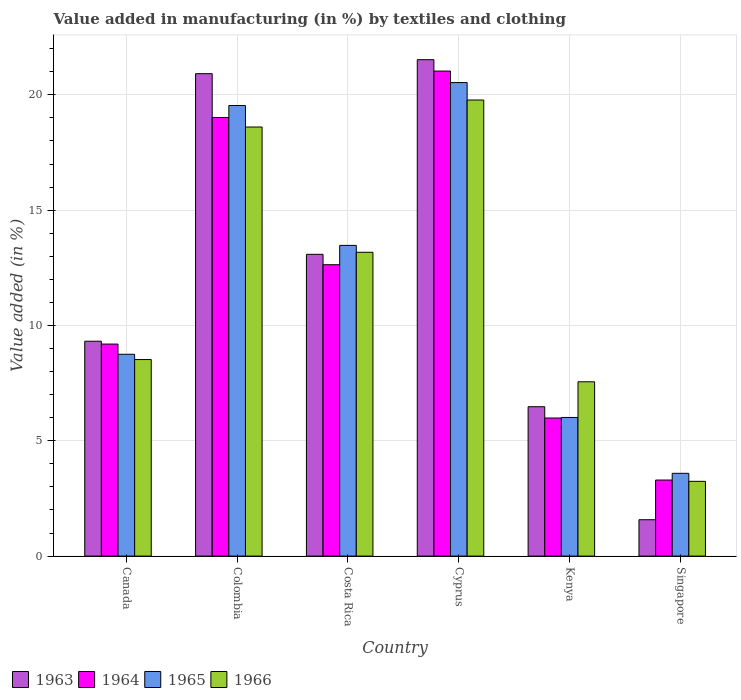How many groups of bars are there?
Offer a terse response. 6. Are the number of bars per tick equal to the number of legend labels?
Your answer should be compact. Yes. Are the number of bars on each tick of the X-axis equal?
Your answer should be compact. Yes. How many bars are there on the 5th tick from the left?
Your response must be concise. 4. How many bars are there on the 3rd tick from the right?
Provide a short and direct response. 4. What is the percentage of value added in manufacturing by textiles and clothing in 1965 in Colombia?
Your answer should be compact. 19.54. Across all countries, what is the maximum percentage of value added in manufacturing by textiles and clothing in 1966?
Ensure brevity in your answer.  19.78. Across all countries, what is the minimum percentage of value added in manufacturing by textiles and clothing in 1964?
Your answer should be very brief. 3.3. In which country was the percentage of value added in manufacturing by textiles and clothing in 1964 maximum?
Offer a terse response. Cyprus. In which country was the percentage of value added in manufacturing by textiles and clothing in 1966 minimum?
Give a very brief answer. Singapore. What is the total percentage of value added in manufacturing by textiles and clothing in 1965 in the graph?
Your answer should be compact. 71.89. What is the difference between the percentage of value added in manufacturing by textiles and clothing in 1963 in Colombia and that in Kenya?
Provide a short and direct response. 14.44. What is the difference between the percentage of value added in manufacturing by textiles and clothing in 1965 in Kenya and the percentage of value added in manufacturing by textiles and clothing in 1966 in Singapore?
Give a very brief answer. 2.77. What is the average percentage of value added in manufacturing by textiles and clothing in 1964 per country?
Keep it short and to the point. 11.86. What is the difference between the percentage of value added in manufacturing by textiles and clothing of/in 1963 and percentage of value added in manufacturing by textiles and clothing of/in 1965 in Cyprus?
Provide a short and direct response. 0.99. In how many countries, is the percentage of value added in manufacturing by textiles and clothing in 1964 greater than 7 %?
Offer a terse response. 4. What is the ratio of the percentage of value added in manufacturing by textiles and clothing in 1964 in Costa Rica to that in Cyprus?
Provide a succinct answer. 0.6. What is the difference between the highest and the second highest percentage of value added in manufacturing by textiles and clothing in 1964?
Your response must be concise. 6.38. What is the difference between the highest and the lowest percentage of value added in manufacturing by textiles and clothing in 1965?
Offer a terse response. 16.94. In how many countries, is the percentage of value added in manufacturing by textiles and clothing in 1963 greater than the average percentage of value added in manufacturing by textiles and clothing in 1963 taken over all countries?
Give a very brief answer. 3. What does the 1st bar from the left in Singapore represents?
Provide a short and direct response. 1963. What does the 1st bar from the right in Kenya represents?
Offer a very short reply. 1966. Is it the case that in every country, the sum of the percentage of value added in manufacturing by textiles and clothing in 1964 and percentage of value added in manufacturing by textiles and clothing in 1965 is greater than the percentage of value added in manufacturing by textiles and clothing in 1963?
Provide a short and direct response. Yes. Are all the bars in the graph horizontal?
Make the answer very short. No. What is the difference between two consecutive major ticks on the Y-axis?
Keep it short and to the point. 5. Are the values on the major ticks of Y-axis written in scientific E-notation?
Offer a very short reply. No. How many legend labels are there?
Offer a very short reply. 4. How are the legend labels stacked?
Your answer should be very brief. Horizontal. What is the title of the graph?
Offer a terse response. Value added in manufacturing (in %) by textiles and clothing. Does "1991" appear as one of the legend labels in the graph?
Provide a succinct answer. No. What is the label or title of the X-axis?
Offer a terse response. Country. What is the label or title of the Y-axis?
Provide a short and direct response. Value added (in %). What is the Value added (in %) in 1963 in Canada?
Offer a very short reply. 9.32. What is the Value added (in %) in 1964 in Canada?
Make the answer very short. 9.19. What is the Value added (in %) in 1965 in Canada?
Your answer should be very brief. 8.75. What is the Value added (in %) of 1966 in Canada?
Give a very brief answer. 8.52. What is the Value added (in %) in 1963 in Colombia?
Your answer should be compact. 20.92. What is the Value added (in %) in 1964 in Colombia?
Offer a terse response. 19.02. What is the Value added (in %) of 1965 in Colombia?
Offer a terse response. 19.54. What is the Value added (in %) in 1966 in Colombia?
Provide a short and direct response. 18.6. What is the Value added (in %) of 1963 in Costa Rica?
Your answer should be compact. 13.08. What is the Value added (in %) in 1964 in Costa Rica?
Keep it short and to the point. 12.63. What is the Value added (in %) in 1965 in Costa Rica?
Offer a very short reply. 13.47. What is the Value added (in %) in 1966 in Costa Rica?
Keep it short and to the point. 13.17. What is the Value added (in %) in 1963 in Cyprus?
Ensure brevity in your answer.  21.52. What is the Value added (in %) in 1964 in Cyprus?
Ensure brevity in your answer.  21.03. What is the Value added (in %) in 1965 in Cyprus?
Make the answer very short. 20.53. What is the Value added (in %) in 1966 in Cyprus?
Give a very brief answer. 19.78. What is the Value added (in %) of 1963 in Kenya?
Offer a terse response. 6.48. What is the Value added (in %) in 1964 in Kenya?
Your answer should be compact. 5.99. What is the Value added (in %) of 1965 in Kenya?
Make the answer very short. 6.01. What is the Value added (in %) in 1966 in Kenya?
Your answer should be compact. 7.56. What is the Value added (in %) in 1963 in Singapore?
Provide a succinct answer. 1.58. What is the Value added (in %) in 1964 in Singapore?
Your response must be concise. 3.3. What is the Value added (in %) in 1965 in Singapore?
Keep it short and to the point. 3.59. What is the Value added (in %) in 1966 in Singapore?
Ensure brevity in your answer.  3.24. Across all countries, what is the maximum Value added (in %) of 1963?
Offer a very short reply. 21.52. Across all countries, what is the maximum Value added (in %) in 1964?
Your response must be concise. 21.03. Across all countries, what is the maximum Value added (in %) in 1965?
Your answer should be compact. 20.53. Across all countries, what is the maximum Value added (in %) of 1966?
Ensure brevity in your answer.  19.78. Across all countries, what is the minimum Value added (in %) in 1963?
Give a very brief answer. 1.58. Across all countries, what is the minimum Value added (in %) of 1964?
Give a very brief answer. 3.3. Across all countries, what is the minimum Value added (in %) in 1965?
Give a very brief answer. 3.59. Across all countries, what is the minimum Value added (in %) in 1966?
Your answer should be compact. 3.24. What is the total Value added (in %) of 1963 in the graph?
Your response must be concise. 72.9. What is the total Value added (in %) in 1964 in the graph?
Give a very brief answer. 71.16. What is the total Value added (in %) in 1965 in the graph?
Ensure brevity in your answer.  71.89. What is the total Value added (in %) of 1966 in the graph?
Offer a very short reply. 70.87. What is the difference between the Value added (in %) in 1963 in Canada and that in Colombia?
Provide a short and direct response. -11.6. What is the difference between the Value added (in %) of 1964 in Canada and that in Colombia?
Ensure brevity in your answer.  -9.82. What is the difference between the Value added (in %) in 1965 in Canada and that in Colombia?
Provide a succinct answer. -10.79. What is the difference between the Value added (in %) in 1966 in Canada and that in Colombia?
Your answer should be compact. -10.08. What is the difference between the Value added (in %) of 1963 in Canada and that in Costa Rica?
Offer a terse response. -3.77. What is the difference between the Value added (in %) of 1964 in Canada and that in Costa Rica?
Make the answer very short. -3.44. What is the difference between the Value added (in %) in 1965 in Canada and that in Costa Rica?
Ensure brevity in your answer.  -4.72. What is the difference between the Value added (in %) in 1966 in Canada and that in Costa Rica?
Provide a short and direct response. -4.65. What is the difference between the Value added (in %) in 1963 in Canada and that in Cyprus?
Offer a very short reply. -12.21. What is the difference between the Value added (in %) in 1964 in Canada and that in Cyprus?
Your answer should be very brief. -11.84. What is the difference between the Value added (in %) in 1965 in Canada and that in Cyprus?
Your response must be concise. -11.78. What is the difference between the Value added (in %) of 1966 in Canada and that in Cyprus?
Ensure brevity in your answer.  -11.25. What is the difference between the Value added (in %) in 1963 in Canada and that in Kenya?
Offer a very short reply. 2.84. What is the difference between the Value added (in %) in 1964 in Canada and that in Kenya?
Offer a very short reply. 3.21. What is the difference between the Value added (in %) in 1965 in Canada and that in Kenya?
Keep it short and to the point. 2.74. What is the difference between the Value added (in %) of 1966 in Canada and that in Kenya?
Your answer should be very brief. 0.96. What is the difference between the Value added (in %) in 1963 in Canada and that in Singapore?
Provide a succinct answer. 7.74. What is the difference between the Value added (in %) in 1964 in Canada and that in Singapore?
Give a very brief answer. 5.9. What is the difference between the Value added (in %) in 1965 in Canada and that in Singapore?
Ensure brevity in your answer.  5.16. What is the difference between the Value added (in %) of 1966 in Canada and that in Singapore?
Your response must be concise. 5.28. What is the difference between the Value added (in %) in 1963 in Colombia and that in Costa Rica?
Offer a terse response. 7.83. What is the difference between the Value added (in %) in 1964 in Colombia and that in Costa Rica?
Ensure brevity in your answer.  6.38. What is the difference between the Value added (in %) in 1965 in Colombia and that in Costa Rica?
Your answer should be compact. 6.06. What is the difference between the Value added (in %) of 1966 in Colombia and that in Costa Rica?
Provide a short and direct response. 5.43. What is the difference between the Value added (in %) of 1963 in Colombia and that in Cyprus?
Keep it short and to the point. -0.61. What is the difference between the Value added (in %) of 1964 in Colombia and that in Cyprus?
Your answer should be very brief. -2.01. What is the difference between the Value added (in %) of 1965 in Colombia and that in Cyprus?
Your response must be concise. -0.99. What is the difference between the Value added (in %) of 1966 in Colombia and that in Cyprus?
Your answer should be very brief. -1.17. What is the difference between the Value added (in %) of 1963 in Colombia and that in Kenya?
Provide a short and direct response. 14.44. What is the difference between the Value added (in %) of 1964 in Colombia and that in Kenya?
Offer a very short reply. 13.03. What is the difference between the Value added (in %) of 1965 in Colombia and that in Kenya?
Your answer should be compact. 13.53. What is the difference between the Value added (in %) in 1966 in Colombia and that in Kenya?
Your answer should be very brief. 11.05. What is the difference between the Value added (in %) of 1963 in Colombia and that in Singapore?
Offer a very short reply. 19.34. What is the difference between the Value added (in %) of 1964 in Colombia and that in Singapore?
Your answer should be compact. 15.72. What is the difference between the Value added (in %) of 1965 in Colombia and that in Singapore?
Your answer should be compact. 15.95. What is the difference between the Value added (in %) in 1966 in Colombia and that in Singapore?
Give a very brief answer. 15.36. What is the difference between the Value added (in %) of 1963 in Costa Rica and that in Cyprus?
Your answer should be very brief. -8.44. What is the difference between the Value added (in %) of 1964 in Costa Rica and that in Cyprus?
Provide a succinct answer. -8.4. What is the difference between the Value added (in %) of 1965 in Costa Rica and that in Cyprus?
Your answer should be compact. -7.06. What is the difference between the Value added (in %) of 1966 in Costa Rica and that in Cyprus?
Give a very brief answer. -6.6. What is the difference between the Value added (in %) of 1963 in Costa Rica and that in Kenya?
Give a very brief answer. 6.61. What is the difference between the Value added (in %) of 1964 in Costa Rica and that in Kenya?
Your response must be concise. 6.65. What is the difference between the Value added (in %) in 1965 in Costa Rica and that in Kenya?
Make the answer very short. 7.46. What is the difference between the Value added (in %) in 1966 in Costa Rica and that in Kenya?
Ensure brevity in your answer.  5.62. What is the difference between the Value added (in %) in 1963 in Costa Rica and that in Singapore?
Your answer should be compact. 11.51. What is the difference between the Value added (in %) in 1964 in Costa Rica and that in Singapore?
Give a very brief answer. 9.34. What is the difference between the Value added (in %) in 1965 in Costa Rica and that in Singapore?
Give a very brief answer. 9.88. What is the difference between the Value added (in %) in 1966 in Costa Rica and that in Singapore?
Offer a terse response. 9.93. What is the difference between the Value added (in %) in 1963 in Cyprus and that in Kenya?
Give a very brief answer. 15.05. What is the difference between the Value added (in %) in 1964 in Cyprus and that in Kenya?
Offer a very short reply. 15.04. What is the difference between the Value added (in %) of 1965 in Cyprus and that in Kenya?
Offer a terse response. 14.52. What is the difference between the Value added (in %) in 1966 in Cyprus and that in Kenya?
Your response must be concise. 12.22. What is the difference between the Value added (in %) of 1963 in Cyprus and that in Singapore?
Provide a short and direct response. 19.95. What is the difference between the Value added (in %) in 1964 in Cyprus and that in Singapore?
Provide a short and direct response. 17.73. What is the difference between the Value added (in %) in 1965 in Cyprus and that in Singapore?
Your answer should be very brief. 16.94. What is the difference between the Value added (in %) in 1966 in Cyprus and that in Singapore?
Make the answer very short. 16.53. What is the difference between the Value added (in %) in 1963 in Kenya and that in Singapore?
Your answer should be very brief. 4.9. What is the difference between the Value added (in %) of 1964 in Kenya and that in Singapore?
Offer a very short reply. 2.69. What is the difference between the Value added (in %) in 1965 in Kenya and that in Singapore?
Your answer should be very brief. 2.42. What is the difference between the Value added (in %) in 1966 in Kenya and that in Singapore?
Offer a terse response. 4.32. What is the difference between the Value added (in %) of 1963 in Canada and the Value added (in %) of 1964 in Colombia?
Offer a very short reply. -9.7. What is the difference between the Value added (in %) in 1963 in Canada and the Value added (in %) in 1965 in Colombia?
Make the answer very short. -10.22. What is the difference between the Value added (in %) in 1963 in Canada and the Value added (in %) in 1966 in Colombia?
Provide a short and direct response. -9.29. What is the difference between the Value added (in %) of 1964 in Canada and the Value added (in %) of 1965 in Colombia?
Keep it short and to the point. -10.34. What is the difference between the Value added (in %) of 1964 in Canada and the Value added (in %) of 1966 in Colombia?
Keep it short and to the point. -9.41. What is the difference between the Value added (in %) of 1965 in Canada and the Value added (in %) of 1966 in Colombia?
Provide a short and direct response. -9.85. What is the difference between the Value added (in %) in 1963 in Canada and the Value added (in %) in 1964 in Costa Rica?
Offer a terse response. -3.32. What is the difference between the Value added (in %) in 1963 in Canada and the Value added (in %) in 1965 in Costa Rica?
Keep it short and to the point. -4.16. What is the difference between the Value added (in %) in 1963 in Canada and the Value added (in %) in 1966 in Costa Rica?
Give a very brief answer. -3.86. What is the difference between the Value added (in %) of 1964 in Canada and the Value added (in %) of 1965 in Costa Rica?
Offer a very short reply. -4.28. What is the difference between the Value added (in %) in 1964 in Canada and the Value added (in %) in 1966 in Costa Rica?
Make the answer very short. -3.98. What is the difference between the Value added (in %) in 1965 in Canada and the Value added (in %) in 1966 in Costa Rica?
Provide a succinct answer. -4.42. What is the difference between the Value added (in %) in 1963 in Canada and the Value added (in %) in 1964 in Cyprus?
Provide a succinct answer. -11.71. What is the difference between the Value added (in %) in 1963 in Canada and the Value added (in %) in 1965 in Cyprus?
Provide a succinct answer. -11.21. What is the difference between the Value added (in %) in 1963 in Canada and the Value added (in %) in 1966 in Cyprus?
Make the answer very short. -10.46. What is the difference between the Value added (in %) in 1964 in Canada and the Value added (in %) in 1965 in Cyprus?
Your answer should be compact. -11.34. What is the difference between the Value added (in %) of 1964 in Canada and the Value added (in %) of 1966 in Cyprus?
Offer a terse response. -10.58. What is the difference between the Value added (in %) in 1965 in Canada and the Value added (in %) in 1966 in Cyprus?
Provide a short and direct response. -11.02. What is the difference between the Value added (in %) of 1963 in Canada and the Value added (in %) of 1964 in Kenya?
Your response must be concise. 3.33. What is the difference between the Value added (in %) of 1963 in Canada and the Value added (in %) of 1965 in Kenya?
Provide a short and direct response. 3.31. What is the difference between the Value added (in %) of 1963 in Canada and the Value added (in %) of 1966 in Kenya?
Offer a very short reply. 1.76. What is the difference between the Value added (in %) of 1964 in Canada and the Value added (in %) of 1965 in Kenya?
Keep it short and to the point. 3.18. What is the difference between the Value added (in %) of 1964 in Canada and the Value added (in %) of 1966 in Kenya?
Offer a very short reply. 1.64. What is the difference between the Value added (in %) of 1965 in Canada and the Value added (in %) of 1966 in Kenya?
Give a very brief answer. 1.19. What is the difference between the Value added (in %) in 1963 in Canada and the Value added (in %) in 1964 in Singapore?
Your response must be concise. 6.02. What is the difference between the Value added (in %) in 1963 in Canada and the Value added (in %) in 1965 in Singapore?
Your response must be concise. 5.73. What is the difference between the Value added (in %) in 1963 in Canada and the Value added (in %) in 1966 in Singapore?
Ensure brevity in your answer.  6.08. What is the difference between the Value added (in %) in 1964 in Canada and the Value added (in %) in 1965 in Singapore?
Give a very brief answer. 5.6. What is the difference between the Value added (in %) in 1964 in Canada and the Value added (in %) in 1966 in Singapore?
Your answer should be very brief. 5.95. What is the difference between the Value added (in %) of 1965 in Canada and the Value added (in %) of 1966 in Singapore?
Keep it short and to the point. 5.51. What is the difference between the Value added (in %) in 1963 in Colombia and the Value added (in %) in 1964 in Costa Rica?
Provide a succinct answer. 8.28. What is the difference between the Value added (in %) in 1963 in Colombia and the Value added (in %) in 1965 in Costa Rica?
Give a very brief answer. 7.44. What is the difference between the Value added (in %) of 1963 in Colombia and the Value added (in %) of 1966 in Costa Rica?
Offer a terse response. 7.74. What is the difference between the Value added (in %) in 1964 in Colombia and the Value added (in %) in 1965 in Costa Rica?
Keep it short and to the point. 5.55. What is the difference between the Value added (in %) in 1964 in Colombia and the Value added (in %) in 1966 in Costa Rica?
Your answer should be very brief. 5.84. What is the difference between the Value added (in %) of 1965 in Colombia and the Value added (in %) of 1966 in Costa Rica?
Give a very brief answer. 6.36. What is the difference between the Value added (in %) in 1963 in Colombia and the Value added (in %) in 1964 in Cyprus?
Give a very brief answer. -0.11. What is the difference between the Value added (in %) in 1963 in Colombia and the Value added (in %) in 1965 in Cyprus?
Ensure brevity in your answer.  0.39. What is the difference between the Value added (in %) of 1963 in Colombia and the Value added (in %) of 1966 in Cyprus?
Ensure brevity in your answer.  1.14. What is the difference between the Value added (in %) of 1964 in Colombia and the Value added (in %) of 1965 in Cyprus?
Keep it short and to the point. -1.51. What is the difference between the Value added (in %) in 1964 in Colombia and the Value added (in %) in 1966 in Cyprus?
Give a very brief answer. -0.76. What is the difference between the Value added (in %) in 1965 in Colombia and the Value added (in %) in 1966 in Cyprus?
Give a very brief answer. -0.24. What is the difference between the Value added (in %) in 1963 in Colombia and the Value added (in %) in 1964 in Kenya?
Keep it short and to the point. 14.93. What is the difference between the Value added (in %) in 1963 in Colombia and the Value added (in %) in 1965 in Kenya?
Make the answer very short. 14.91. What is the difference between the Value added (in %) in 1963 in Colombia and the Value added (in %) in 1966 in Kenya?
Provide a short and direct response. 13.36. What is the difference between the Value added (in %) in 1964 in Colombia and the Value added (in %) in 1965 in Kenya?
Ensure brevity in your answer.  13.01. What is the difference between the Value added (in %) in 1964 in Colombia and the Value added (in %) in 1966 in Kenya?
Provide a succinct answer. 11.46. What is the difference between the Value added (in %) in 1965 in Colombia and the Value added (in %) in 1966 in Kenya?
Provide a short and direct response. 11.98. What is the difference between the Value added (in %) in 1963 in Colombia and the Value added (in %) in 1964 in Singapore?
Offer a terse response. 17.62. What is the difference between the Value added (in %) in 1963 in Colombia and the Value added (in %) in 1965 in Singapore?
Keep it short and to the point. 17.33. What is the difference between the Value added (in %) of 1963 in Colombia and the Value added (in %) of 1966 in Singapore?
Your answer should be very brief. 17.68. What is the difference between the Value added (in %) in 1964 in Colombia and the Value added (in %) in 1965 in Singapore?
Your answer should be compact. 15.43. What is the difference between the Value added (in %) of 1964 in Colombia and the Value added (in %) of 1966 in Singapore?
Provide a succinct answer. 15.78. What is the difference between the Value added (in %) in 1965 in Colombia and the Value added (in %) in 1966 in Singapore?
Offer a terse response. 16.3. What is the difference between the Value added (in %) of 1963 in Costa Rica and the Value added (in %) of 1964 in Cyprus?
Give a very brief answer. -7.95. What is the difference between the Value added (in %) of 1963 in Costa Rica and the Value added (in %) of 1965 in Cyprus?
Ensure brevity in your answer.  -7.45. What is the difference between the Value added (in %) of 1963 in Costa Rica and the Value added (in %) of 1966 in Cyprus?
Your response must be concise. -6.69. What is the difference between the Value added (in %) in 1964 in Costa Rica and the Value added (in %) in 1965 in Cyprus?
Your answer should be compact. -7.9. What is the difference between the Value added (in %) in 1964 in Costa Rica and the Value added (in %) in 1966 in Cyprus?
Give a very brief answer. -7.14. What is the difference between the Value added (in %) of 1965 in Costa Rica and the Value added (in %) of 1966 in Cyprus?
Provide a short and direct response. -6.3. What is the difference between the Value added (in %) of 1963 in Costa Rica and the Value added (in %) of 1964 in Kenya?
Your answer should be compact. 7.1. What is the difference between the Value added (in %) in 1963 in Costa Rica and the Value added (in %) in 1965 in Kenya?
Make the answer very short. 7.07. What is the difference between the Value added (in %) of 1963 in Costa Rica and the Value added (in %) of 1966 in Kenya?
Offer a very short reply. 5.53. What is the difference between the Value added (in %) in 1964 in Costa Rica and the Value added (in %) in 1965 in Kenya?
Offer a very short reply. 6.62. What is the difference between the Value added (in %) in 1964 in Costa Rica and the Value added (in %) in 1966 in Kenya?
Provide a short and direct response. 5.08. What is the difference between the Value added (in %) in 1965 in Costa Rica and the Value added (in %) in 1966 in Kenya?
Your response must be concise. 5.91. What is the difference between the Value added (in %) of 1963 in Costa Rica and the Value added (in %) of 1964 in Singapore?
Your answer should be compact. 9.79. What is the difference between the Value added (in %) of 1963 in Costa Rica and the Value added (in %) of 1965 in Singapore?
Give a very brief answer. 9.5. What is the difference between the Value added (in %) of 1963 in Costa Rica and the Value added (in %) of 1966 in Singapore?
Ensure brevity in your answer.  9.84. What is the difference between the Value added (in %) of 1964 in Costa Rica and the Value added (in %) of 1965 in Singapore?
Your answer should be compact. 9.04. What is the difference between the Value added (in %) of 1964 in Costa Rica and the Value added (in %) of 1966 in Singapore?
Keep it short and to the point. 9.39. What is the difference between the Value added (in %) of 1965 in Costa Rica and the Value added (in %) of 1966 in Singapore?
Make the answer very short. 10.23. What is the difference between the Value added (in %) of 1963 in Cyprus and the Value added (in %) of 1964 in Kenya?
Provide a succinct answer. 15.54. What is the difference between the Value added (in %) of 1963 in Cyprus and the Value added (in %) of 1965 in Kenya?
Provide a succinct answer. 15.51. What is the difference between the Value added (in %) of 1963 in Cyprus and the Value added (in %) of 1966 in Kenya?
Your response must be concise. 13.97. What is the difference between the Value added (in %) in 1964 in Cyprus and the Value added (in %) in 1965 in Kenya?
Make the answer very short. 15.02. What is the difference between the Value added (in %) in 1964 in Cyprus and the Value added (in %) in 1966 in Kenya?
Keep it short and to the point. 13.47. What is the difference between the Value added (in %) of 1965 in Cyprus and the Value added (in %) of 1966 in Kenya?
Keep it short and to the point. 12.97. What is the difference between the Value added (in %) of 1963 in Cyprus and the Value added (in %) of 1964 in Singapore?
Offer a very short reply. 18.23. What is the difference between the Value added (in %) of 1963 in Cyprus and the Value added (in %) of 1965 in Singapore?
Give a very brief answer. 17.93. What is the difference between the Value added (in %) of 1963 in Cyprus and the Value added (in %) of 1966 in Singapore?
Your response must be concise. 18.28. What is the difference between the Value added (in %) in 1964 in Cyprus and the Value added (in %) in 1965 in Singapore?
Ensure brevity in your answer.  17.44. What is the difference between the Value added (in %) in 1964 in Cyprus and the Value added (in %) in 1966 in Singapore?
Your answer should be compact. 17.79. What is the difference between the Value added (in %) of 1965 in Cyprus and the Value added (in %) of 1966 in Singapore?
Give a very brief answer. 17.29. What is the difference between the Value added (in %) of 1963 in Kenya and the Value added (in %) of 1964 in Singapore?
Offer a very short reply. 3.18. What is the difference between the Value added (in %) in 1963 in Kenya and the Value added (in %) in 1965 in Singapore?
Ensure brevity in your answer.  2.89. What is the difference between the Value added (in %) in 1963 in Kenya and the Value added (in %) in 1966 in Singapore?
Keep it short and to the point. 3.24. What is the difference between the Value added (in %) in 1964 in Kenya and the Value added (in %) in 1965 in Singapore?
Keep it short and to the point. 2.4. What is the difference between the Value added (in %) of 1964 in Kenya and the Value added (in %) of 1966 in Singapore?
Your answer should be very brief. 2.75. What is the difference between the Value added (in %) in 1965 in Kenya and the Value added (in %) in 1966 in Singapore?
Offer a terse response. 2.77. What is the average Value added (in %) in 1963 per country?
Give a very brief answer. 12.15. What is the average Value added (in %) in 1964 per country?
Provide a short and direct response. 11.86. What is the average Value added (in %) of 1965 per country?
Offer a terse response. 11.98. What is the average Value added (in %) in 1966 per country?
Offer a terse response. 11.81. What is the difference between the Value added (in %) of 1963 and Value added (in %) of 1964 in Canada?
Provide a short and direct response. 0.12. What is the difference between the Value added (in %) of 1963 and Value added (in %) of 1965 in Canada?
Provide a succinct answer. 0.57. What is the difference between the Value added (in %) of 1963 and Value added (in %) of 1966 in Canada?
Your answer should be compact. 0.8. What is the difference between the Value added (in %) in 1964 and Value added (in %) in 1965 in Canada?
Offer a very short reply. 0.44. What is the difference between the Value added (in %) of 1964 and Value added (in %) of 1966 in Canada?
Provide a short and direct response. 0.67. What is the difference between the Value added (in %) in 1965 and Value added (in %) in 1966 in Canada?
Your answer should be compact. 0.23. What is the difference between the Value added (in %) of 1963 and Value added (in %) of 1964 in Colombia?
Your answer should be compact. 1.9. What is the difference between the Value added (in %) in 1963 and Value added (in %) in 1965 in Colombia?
Provide a short and direct response. 1.38. What is the difference between the Value added (in %) in 1963 and Value added (in %) in 1966 in Colombia?
Your answer should be compact. 2.31. What is the difference between the Value added (in %) of 1964 and Value added (in %) of 1965 in Colombia?
Offer a terse response. -0.52. What is the difference between the Value added (in %) in 1964 and Value added (in %) in 1966 in Colombia?
Keep it short and to the point. 0.41. What is the difference between the Value added (in %) of 1965 and Value added (in %) of 1966 in Colombia?
Keep it short and to the point. 0.93. What is the difference between the Value added (in %) in 1963 and Value added (in %) in 1964 in Costa Rica?
Provide a succinct answer. 0.45. What is the difference between the Value added (in %) of 1963 and Value added (in %) of 1965 in Costa Rica?
Provide a succinct answer. -0.39. What is the difference between the Value added (in %) of 1963 and Value added (in %) of 1966 in Costa Rica?
Provide a succinct answer. -0.09. What is the difference between the Value added (in %) of 1964 and Value added (in %) of 1965 in Costa Rica?
Provide a short and direct response. -0.84. What is the difference between the Value added (in %) of 1964 and Value added (in %) of 1966 in Costa Rica?
Make the answer very short. -0.54. What is the difference between the Value added (in %) in 1965 and Value added (in %) in 1966 in Costa Rica?
Ensure brevity in your answer.  0.3. What is the difference between the Value added (in %) in 1963 and Value added (in %) in 1964 in Cyprus?
Offer a terse response. 0.49. What is the difference between the Value added (in %) of 1963 and Value added (in %) of 1966 in Cyprus?
Keep it short and to the point. 1.75. What is the difference between the Value added (in %) of 1964 and Value added (in %) of 1965 in Cyprus?
Keep it short and to the point. 0.5. What is the difference between the Value added (in %) of 1964 and Value added (in %) of 1966 in Cyprus?
Your answer should be compact. 1.25. What is the difference between the Value added (in %) in 1965 and Value added (in %) in 1966 in Cyprus?
Give a very brief answer. 0.76. What is the difference between the Value added (in %) in 1963 and Value added (in %) in 1964 in Kenya?
Give a very brief answer. 0.49. What is the difference between the Value added (in %) of 1963 and Value added (in %) of 1965 in Kenya?
Your answer should be compact. 0.47. What is the difference between the Value added (in %) of 1963 and Value added (in %) of 1966 in Kenya?
Offer a very short reply. -1.08. What is the difference between the Value added (in %) of 1964 and Value added (in %) of 1965 in Kenya?
Give a very brief answer. -0.02. What is the difference between the Value added (in %) of 1964 and Value added (in %) of 1966 in Kenya?
Your response must be concise. -1.57. What is the difference between the Value added (in %) of 1965 and Value added (in %) of 1966 in Kenya?
Provide a succinct answer. -1.55. What is the difference between the Value added (in %) of 1963 and Value added (in %) of 1964 in Singapore?
Ensure brevity in your answer.  -1.72. What is the difference between the Value added (in %) in 1963 and Value added (in %) in 1965 in Singapore?
Give a very brief answer. -2.01. What is the difference between the Value added (in %) in 1963 and Value added (in %) in 1966 in Singapore?
Make the answer very short. -1.66. What is the difference between the Value added (in %) in 1964 and Value added (in %) in 1965 in Singapore?
Your answer should be compact. -0.29. What is the difference between the Value added (in %) in 1964 and Value added (in %) in 1966 in Singapore?
Make the answer very short. 0.06. What is the difference between the Value added (in %) in 1965 and Value added (in %) in 1966 in Singapore?
Ensure brevity in your answer.  0.35. What is the ratio of the Value added (in %) of 1963 in Canada to that in Colombia?
Offer a terse response. 0.45. What is the ratio of the Value added (in %) of 1964 in Canada to that in Colombia?
Make the answer very short. 0.48. What is the ratio of the Value added (in %) of 1965 in Canada to that in Colombia?
Keep it short and to the point. 0.45. What is the ratio of the Value added (in %) of 1966 in Canada to that in Colombia?
Make the answer very short. 0.46. What is the ratio of the Value added (in %) of 1963 in Canada to that in Costa Rica?
Your answer should be compact. 0.71. What is the ratio of the Value added (in %) in 1964 in Canada to that in Costa Rica?
Give a very brief answer. 0.73. What is the ratio of the Value added (in %) in 1965 in Canada to that in Costa Rica?
Your answer should be very brief. 0.65. What is the ratio of the Value added (in %) in 1966 in Canada to that in Costa Rica?
Provide a succinct answer. 0.65. What is the ratio of the Value added (in %) in 1963 in Canada to that in Cyprus?
Offer a terse response. 0.43. What is the ratio of the Value added (in %) of 1964 in Canada to that in Cyprus?
Provide a short and direct response. 0.44. What is the ratio of the Value added (in %) in 1965 in Canada to that in Cyprus?
Your answer should be compact. 0.43. What is the ratio of the Value added (in %) of 1966 in Canada to that in Cyprus?
Provide a succinct answer. 0.43. What is the ratio of the Value added (in %) in 1963 in Canada to that in Kenya?
Provide a short and direct response. 1.44. What is the ratio of the Value added (in %) of 1964 in Canada to that in Kenya?
Ensure brevity in your answer.  1.54. What is the ratio of the Value added (in %) in 1965 in Canada to that in Kenya?
Provide a short and direct response. 1.46. What is the ratio of the Value added (in %) in 1966 in Canada to that in Kenya?
Your answer should be compact. 1.13. What is the ratio of the Value added (in %) in 1963 in Canada to that in Singapore?
Your answer should be compact. 5.91. What is the ratio of the Value added (in %) of 1964 in Canada to that in Singapore?
Keep it short and to the point. 2.79. What is the ratio of the Value added (in %) of 1965 in Canada to that in Singapore?
Give a very brief answer. 2.44. What is the ratio of the Value added (in %) of 1966 in Canada to that in Singapore?
Offer a terse response. 2.63. What is the ratio of the Value added (in %) in 1963 in Colombia to that in Costa Rica?
Offer a very short reply. 1.6. What is the ratio of the Value added (in %) of 1964 in Colombia to that in Costa Rica?
Ensure brevity in your answer.  1.51. What is the ratio of the Value added (in %) in 1965 in Colombia to that in Costa Rica?
Make the answer very short. 1.45. What is the ratio of the Value added (in %) of 1966 in Colombia to that in Costa Rica?
Offer a terse response. 1.41. What is the ratio of the Value added (in %) of 1963 in Colombia to that in Cyprus?
Your answer should be compact. 0.97. What is the ratio of the Value added (in %) of 1964 in Colombia to that in Cyprus?
Offer a very short reply. 0.9. What is the ratio of the Value added (in %) of 1965 in Colombia to that in Cyprus?
Provide a succinct answer. 0.95. What is the ratio of the Value added (in %) in 1966 in Colombia to that in Cyprus?
Provide a succinct answer. 0.94. What is the ratio of the Value added (in %) of 1963 in Colombia to that in Kenya?
Give a very brief answer. 3.23. What is the ratio of the Value added (in %) in 1964 in Colombia to that in Kenya?
Your answer should be very brief. 3.18. What is the ratio of the Value added (in %) of 1966 in Colombia to that in Kenya?
Provide a short and direct response. 2.46. What is the ratio of the Value added (in %) in 1963 in Colombia to that in Singapore?
Your answer should be compact. 13.26. What is the ratio of the Value added (in %) of 1964 in Colombia to that in Singapore?
Make the answer very short. 5.77. What is the ratio of the Value added (in %) in 1965 in Colombia to that in Singapore?
Give a very brief answer. 5.44. What is the ratio of the Value added (in %) of 1966 in Colombia to that in Singapore?
Provide a short and direct response. 5.74. What is the ratio of the Value added (in %) of 1963 in Costa Rica to that in Cyprus?
Give a very brief answer. 0.61. What is the ratio of the Value added (in %) of 1964 in Costa Rica to that in Cyprus?
Give a very brief answer. 0.6. What is the ratio of the Value added (in %) of 1965 in Costa Rica to that in Cyprus?
Offer a terse response. 0.66. What is the ratio of the Value added (in %) in 1966 in Costa Rica to that in Cyprus?
Your answer should be compact. 0.67. What is the ratio of the Value added (in %) in 1963 in Costa Rica to that in Kenya?
Keep it short and to the point. 2.02. What is the ratio of the Value added (in %) in 1964 in Costa Rica to that in Kenya?
Your answer should be very brief. 2.11. What is the ratio of the Value added (in %) of 1965 in Costa Rica to that in Kenya?
Your answer should be very brief. 2.24. What is the ratio of the Value added (in %) of 1966 in Costa Rica to that in Kenya?
Keep it short and to the point. 1.74. What is the ratio of the Value added (in %) of 1963 in Costa Rica to that in Singapore?
Give a very brief answer. 8.3. What is the ratio of the Value added (in %) of 1964 in Costa Rica to that in Singapore?
Provide a succinct answer. 3.83. What is the ratio of the Value added (in %) in 1965 in Costa Rica to that in Singapore?
Give a very brief answer. 3.75. What is the ratio of the Value added (in %) in 1966 in Costa Rica to that in Singapore?
Offer a terse response. 4.06. What is the ratio of the Value added (in %) of 1963 in Cyprus to that in Kenya?
Offer a terse response. 3.32. What is the ratio of the Value added (in %) in 1964 in Cyprus to that in Kenya?
Your answer should be compact. 3.51. What is the ratio of the Value added (in %) of 1965 in Cyprus to that in Kenya?
Your response must be concise. 3.42. What is the ratio of the Value added (in %) of 1966 in Cyprus to that in Kenya?
Offer a terse response. 2.62. What is the ratio of the Value added (in %) of 1963 in Cyprus to that in Singapore?
Provide a succinct answer. 13.65. What is the ratio of the Value added (in %) of 1964 in Cyprus to that in Singapore?
Provide a succinct answer. 6.38. What is the ratio of the Value added (in %) in 1965 in Cyprus to that in Singapore?
Offer a terse response. 5.72. What is the ratio of the Value added (in %) of 1966 in Cyprus to that in Singapore?
Ensure brevity in your answer.  6.1. What is the ratio of the Value added (in %) of 1963 in Kenya to that in Singapore?
Provide a short and direct response. 4.11. What is the ratio of the Value added (in %) of 1964 in Kenya to that in Singapore?
Your answer should be very brief. 1.82. What is the ratio of the Value added (in %) of 1965 in Kenya to that in Singapore?
Your response must be concise. 1.67. What is the ratio of the Value added (in %) in 1966 in Kenya to that in Singapore?
Give a very brief answer. 2.33. What is the difference between the highest and the second highest Value added (in %) of 1963?
Give a very brief answer. 0.61. What is the difference between the highest and the second highest Value added (in %) in 1964?
Provide a short and direct response. 2.01. What is the difference between the highest and the second highest Value added (in %) in 1965?
Make the answer very short. 0.99. What is the difference between the highest and the second highest Value added (in %) of 1966?
Make the answer very short. 1.17. What is the difference between the highest and the lowest Value added (in %) of 1963?
Your answer should be very brief. 19.95. What is the difference between the highest and the lowest Value added (in %) of 1964?
Keep it short and to the point. 17.73. What is the difference between the highest and the lowest Value added (in %) of 1965?
Offer a terse response. 16.94. What is the difference between the highest and the lowest Value added (in %) in 1966?
Offer a very short reply. 16.53. 